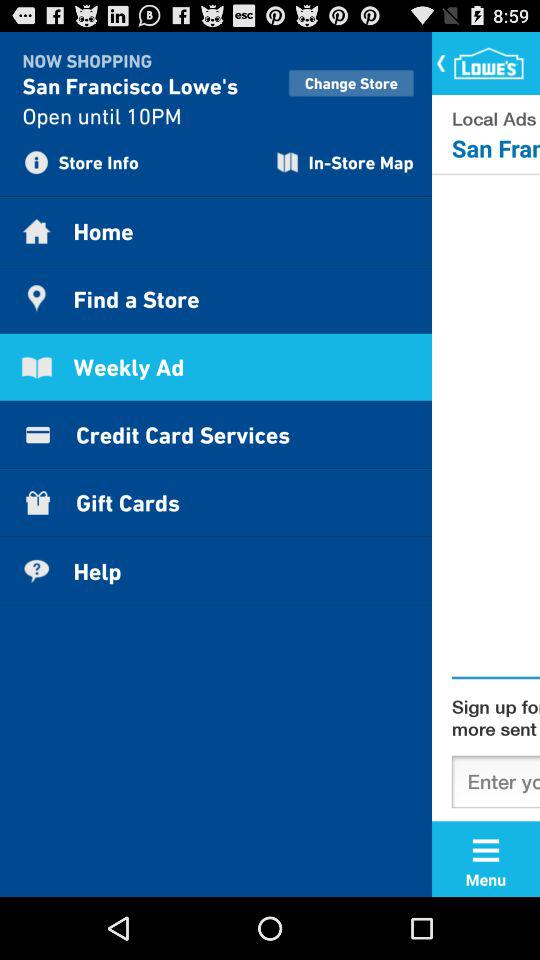On which days is San Francisco Lowe's open?
When the provided information is insufficient, respond with <no answer>. <no answer> 